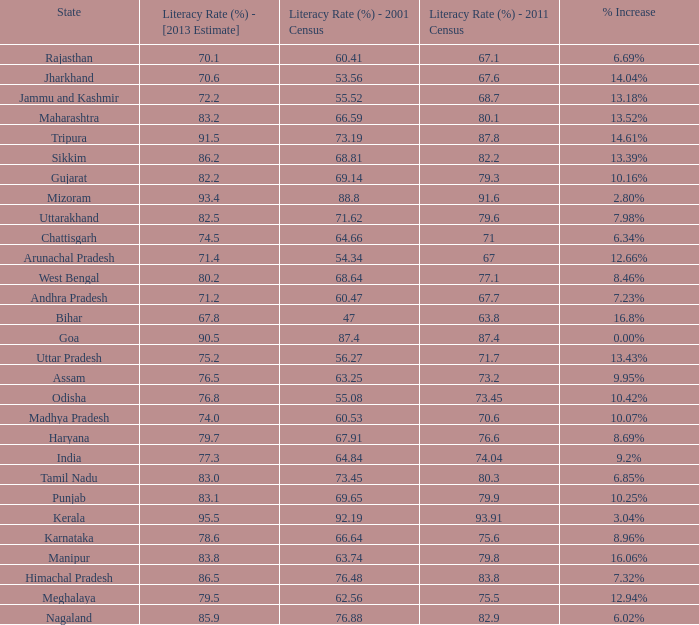What is the average estimated 2013 literacy rate for the states that had a literacy rate of 68.81% in the 2001 census and a literacy rate higher than 79.6% in the 2011 census? 86.2. 